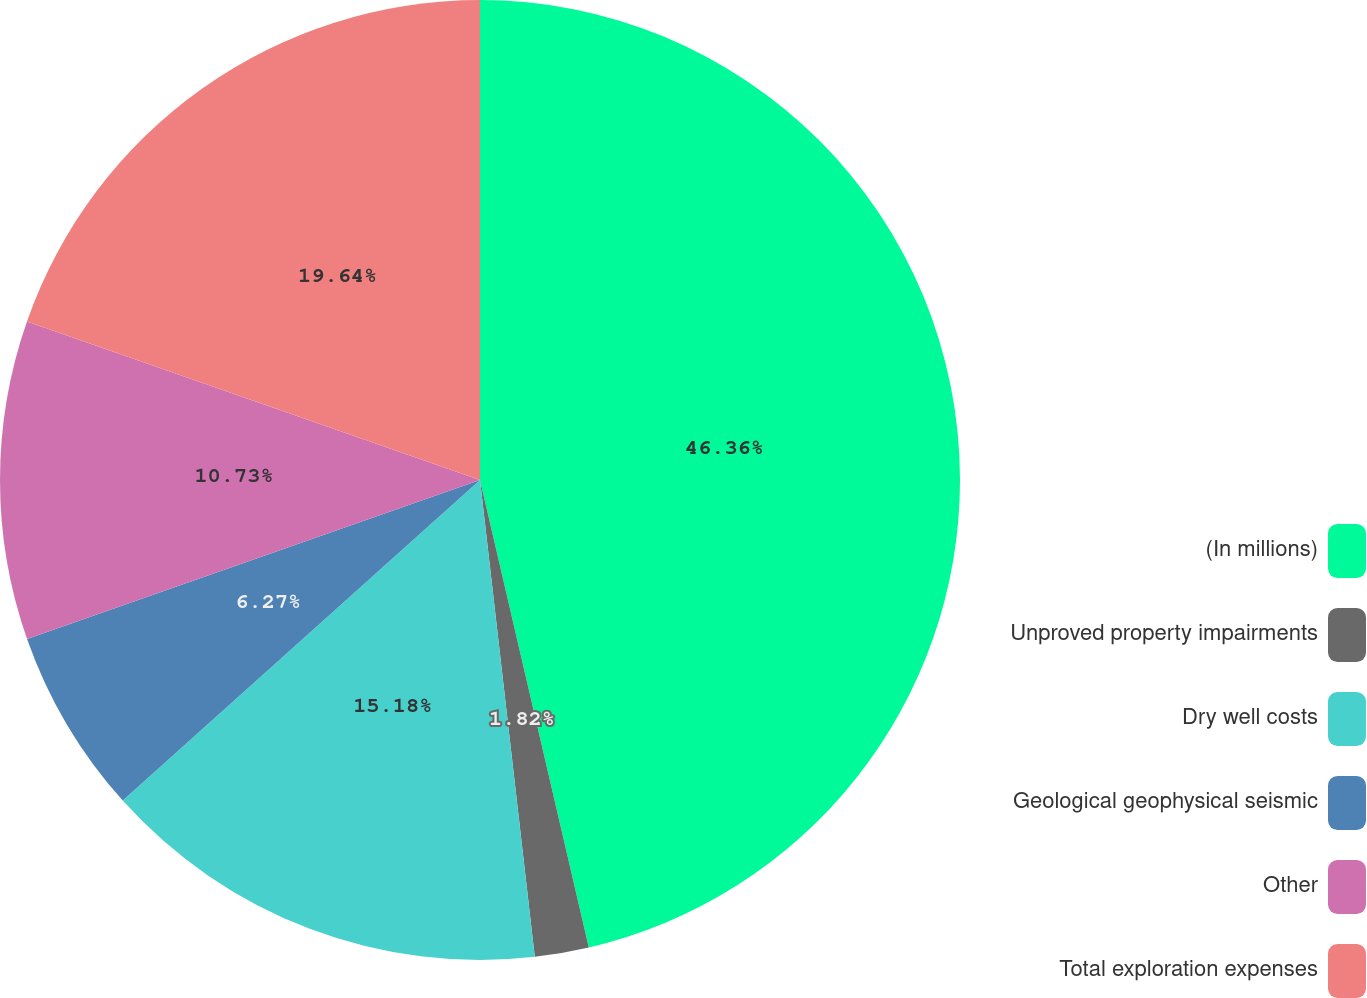<chart> <loc_0><loc_0><loc_500><loc_500><pie_chart><fcel>(In millions)<fcel>Unproved property impairments<fcel>Dry well costs<fcel>Geological geophysical seismic<fcel>Other<fcel>Total exploration expenses<nl><fcel>46.36%<fcel>1.82%<fcel>15.18%<fcel>6.27%<fcel>10.73%<fcel>19.64%<nl></chart> 